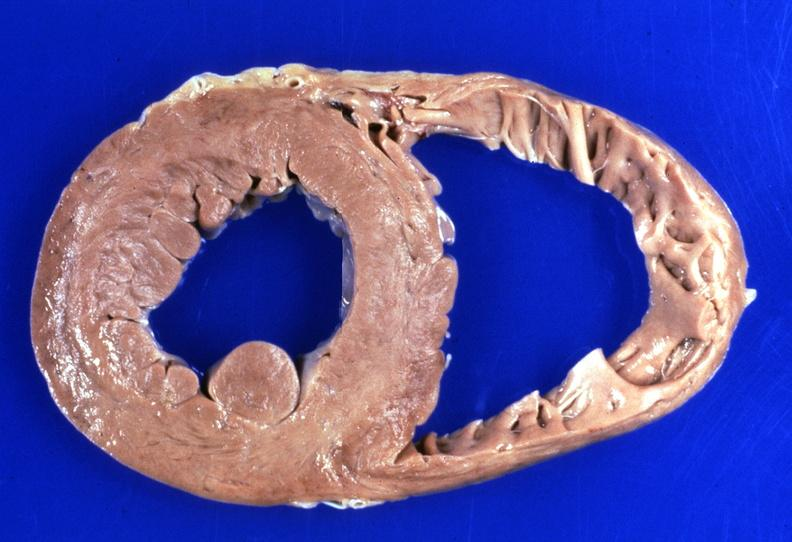does vessel show heart, hemochromatosis?
Answer the question using a single word or phrase. No 